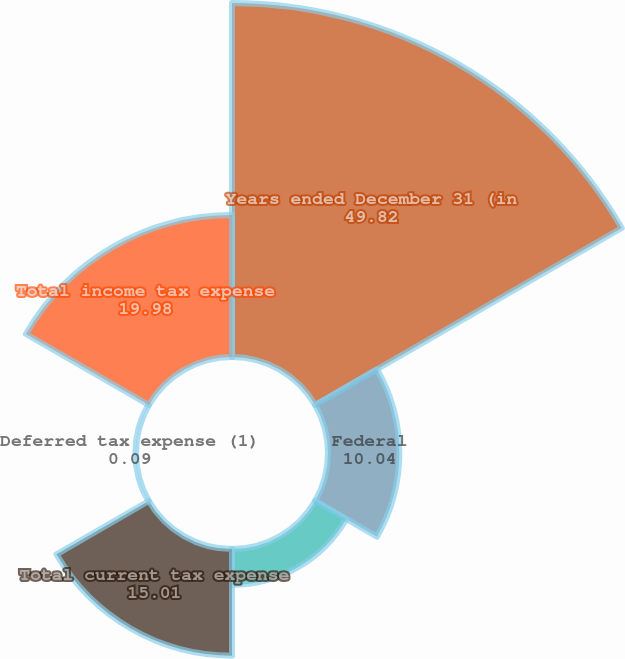Convert chart to OTSL. <chart><loc_0><loc_0><loc_500><loc_500><pie_chart><fcel>Years ended December 31 (in<fcel>Federal<fcel>State<fcel>Total current tax expense<fcel>Deferred tax expense (1)<fcel>Total income tax expense<nl><fcel>49.82%<fcel>10.04%<fcel>5.06%<fcel>15.01%<fcel>0.09%<fcel>19.98%<nl></chart> 